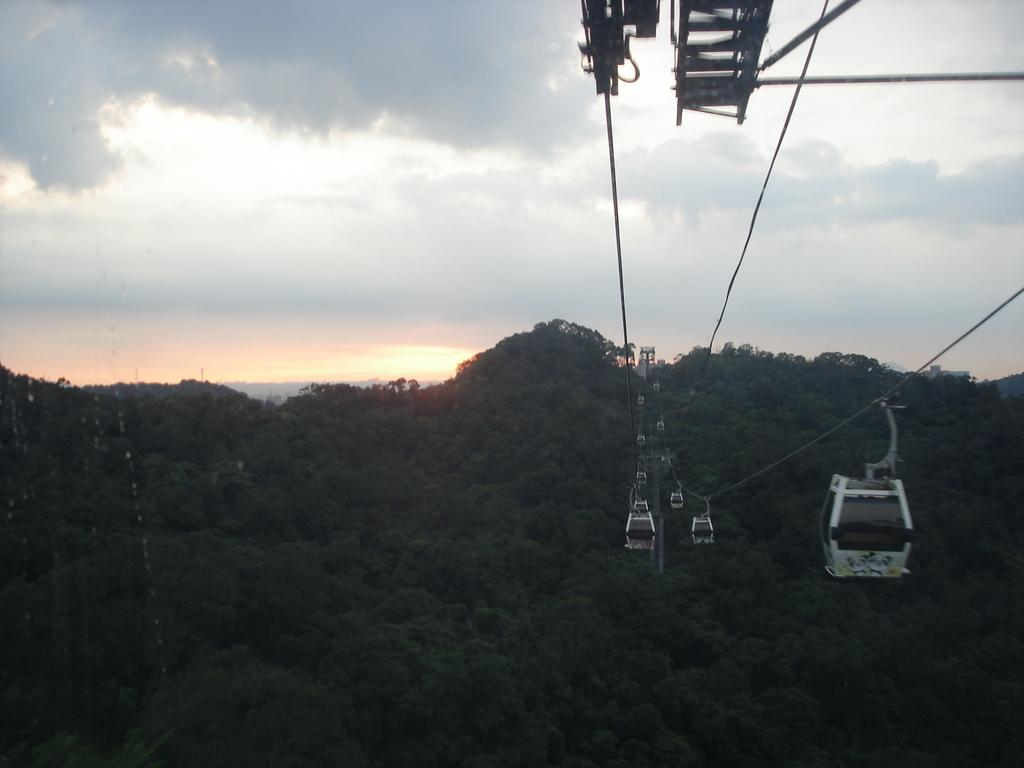What type of transportation can be seen in the image? There is a ropeway in the image. What type of vegetation is visible in the image? There are trees visible in the image. What geographical features can be seen in the background of the image? There are hills in the background of the image. What is visible in the sky in the image? The sky is visible in the background of the image. What type of skin condition can be seen on the trees in the image? There is no mention of any skin condition on the trees in the image; they appear to be healthy. 